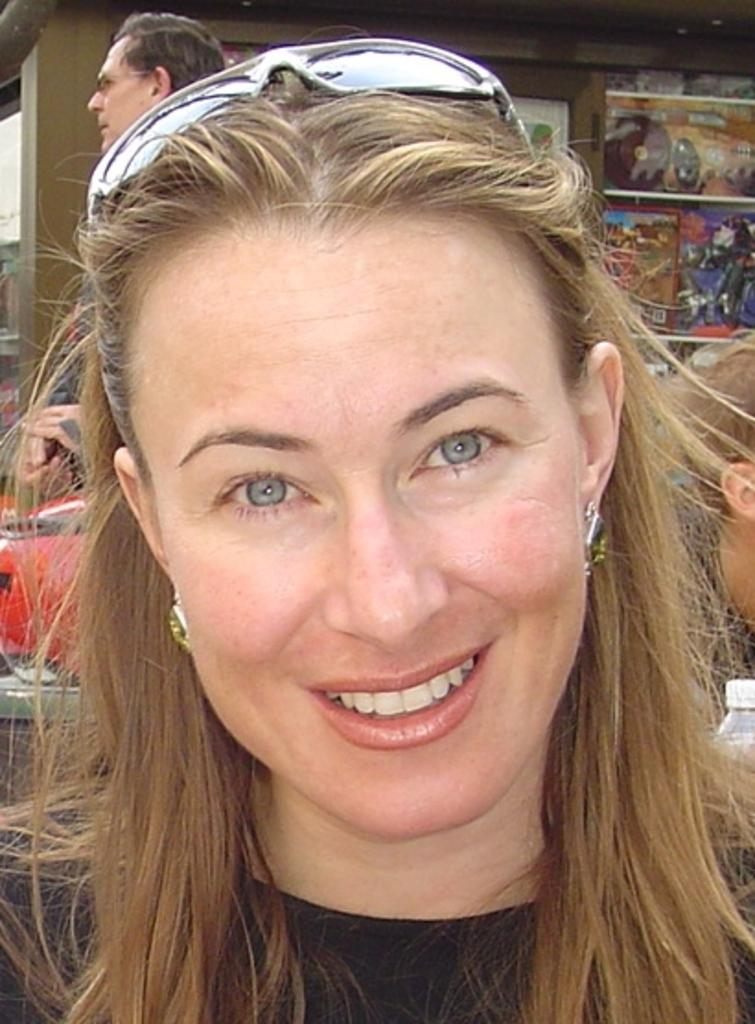Who is the main subject in the image? There is a woman in the image. What is the woman wearing on her head? The woman is wearing goggles on her head. What can be seen in the background of the image? There is a group of persons, a building, and magazines in a rack in the background of the image. What type of song is being played in the background of the image? There is no indication of any song being played in the image. Is there a hospital visible in the image? No, there is no hospital present in the image; it features a woman with goggles on her head and a background with a group of persons, a building, and magazines in a rack. 